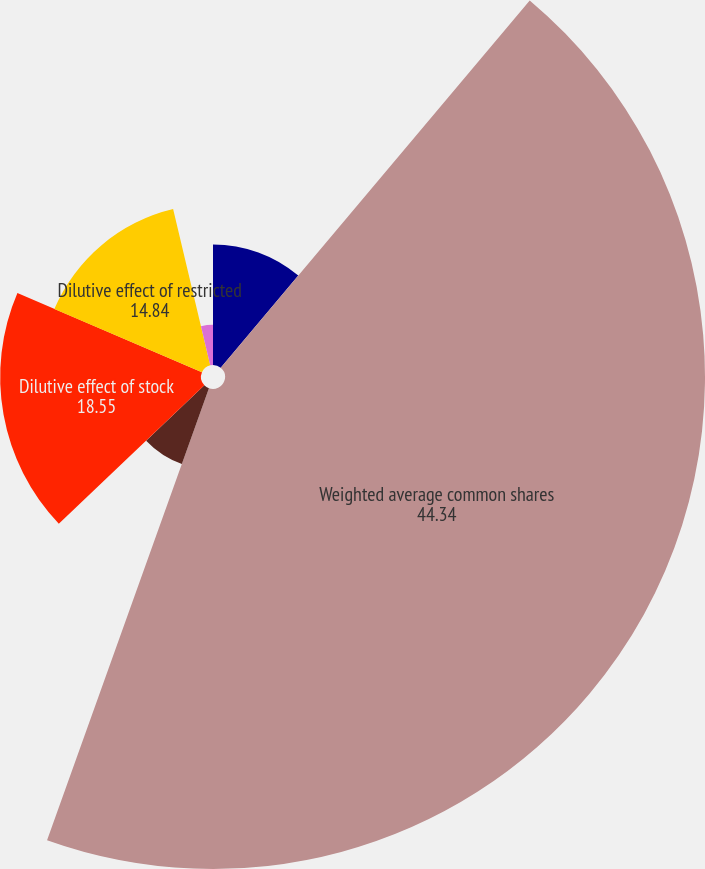Convert chart to OTSL. <chart><loc_0><loc_0><loc_500><loc_500><pie_chart><fcel>Net Income (in millions)<fcel>Weighted average common shares<fcel>Add Participating securities<fcel>Dilutive effect of stock<fcel>Dilutive effect of restricted<fcel>Basic earnings per share<fcel>Diluted earnings per share<nl><fcel>11.13%<fcel>44.34%<fcel>7.42%<fcel>18.55%<fcel>14.84%<fcel>3.71%<fcel>0.0%<nl></chart> 